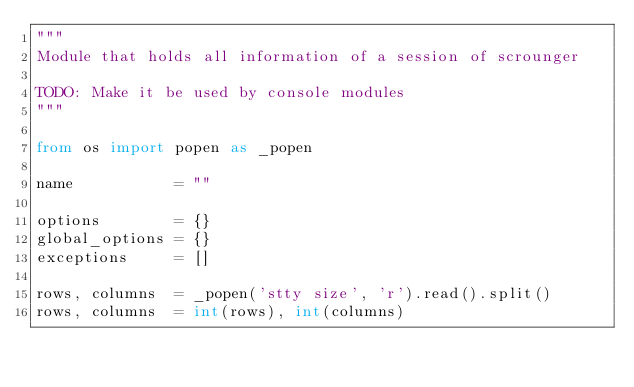<code> <loc_0><loc_0><loc_500><loc_500><_Python_>"""
Module that holds all information of a session of scrounger

TODO: Make it be used by console modules
"""

from os import popen as _popen

name           = ""

options        = {}
global_options = {}
exceptions     = []

rows, columns  = _popen('stty size', 'r').read().split()
rows, columns  = int(rows), int(columns)</code> 